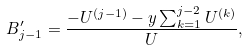<formula> <loc_0><loc_0><loc_500><loc_500>B _ { j - 1 } ^ { \prime } = \frac { - U ^ { ( j - 1 ) } - y \sum _ { k = 1 } ^ { j - 2 } U ^ { ( k ) } } { U } ,</formula> 